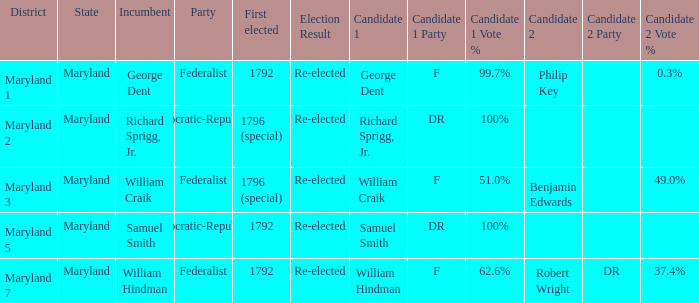What is the party when the existing officeholder is samuel smith? Democratic-Republican. Could you parse the entire table as a dict? {'header': ['District', 'State', 'Incumbent', 'Party', 'First elected', 'Election Result', 'Candidate 1', 'Candidate 1 Party', 'Candidate 1 Vote %', 'Candidate 2', 'Candidate 2 Party', 'Candidate 2 Vote %'], 'rows': [['Maryland 1', 'Maryland', 'George Dent', 'Federalist', '1792', 'Re-elected', 'George Dent', 'F', '99.7%', 'Philip Key', '', '0.3%'], ['Maryland 2', 'Maryland', 'Richard Sprigg, Jr.', 'Democratic-Republican', '1796 (special)', 'Re-elected', 'Richard Sprigg, Jr.', 'DR', '100%', '', '', ''], ['Maryland 3', 'Maryland', 'William Craik', 'Federalist', '1796 (special)', 'Re-elected', 'William Craik', 'F', '51.0%', 'Benjamin Edwards', '', '49.0%'], ['Maryland 5', 'Maryland', 'Samuel Smith', 'Democratic-Republican', '1792', 'Re-elected', 'Samuel Smith', 'DR', '100%', '', '', ''], ['Maryland 7', 'Maryland', 'William Hindman', 'Federalist', '1792', 'Re-elected', 'William Hindman', 'F', '62.6%', 'Robert Wright', 'DR', '37.4%']]} 